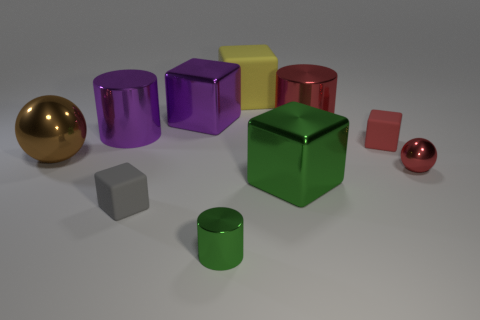Subtract all green blocks. How many blocks are left? 4 Subtract all big purple metal blocks. How many blocks are left? 4 Subtract 1 cubes. How many cubes are left? 4 Subtract all yellow cubes. Subtract all brown cylinders. How many cubes are left? 4 Subtract all balls. How many objects are left? 8 Add 1 metallic balls. How many metallic balls exist? 3 Subtract 0 blue cubes. How many objects are left? 10 Subtract all metal objects. Subtract all purple cubes. How many objects are left? 2 Add 6 purple metallic things. How many purple metallic things are left? 8 